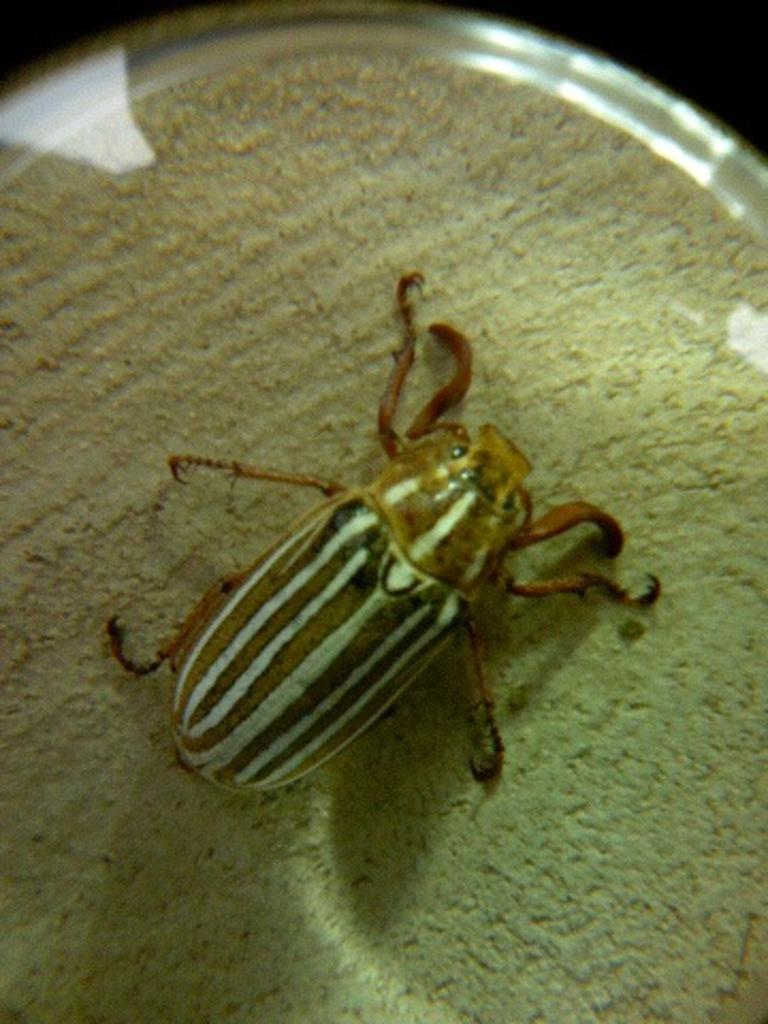What type of creature is present in the image? There is an insect in the image. Where is the insect located in the image? The insect is on the floor. What type of circle is visible in the image? There is no circle present in the image. What type of quilt is the insect resting on in the image? There is no quilt present in the image; the insect is on the floor. What letters can be seen spelling out a word in the image? There are no letters present in the image. 